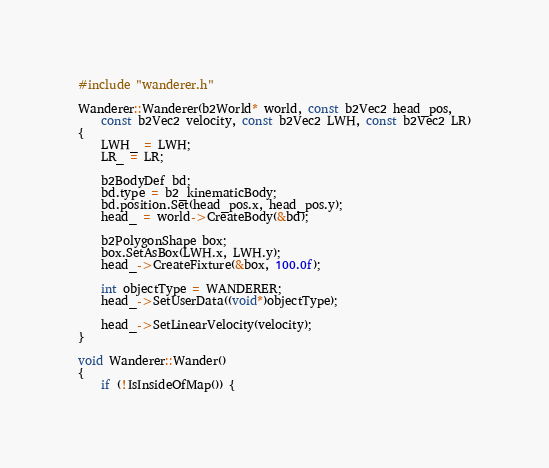Convert code to text. <code><loc_0><loc_0><loc_500><loc_500><_C++_>#include "wanderer.h"

Wanderer::Wanderer(b2World* world, const b2Vec2 head_pos,
    const b2Vec2 velocity, const b2Vec2 LWH, const b2Vec2 LR)
{
    LWH_ = LWH;
    LR_ = LR;

    b2BodyDef bd;
    bd.type = b2_kinematicBody;
    bd.position.Set(head_pos.x, head_pos.y);
    head_ = world->CreateBody(&bd);

    b2PolygonShape box;
    box.SetAsBox(LWH.x, LWH.y);
    head_->CreateFixture(&box, 100.0f);

    int objectType = WANDERER;
    head_->SetUserData((void*)objectType);

    head_->SetLinearVelocity(velocity);
}

void Wanderer::Wander()
{
    if (!IsInsideOfMap()) {</code> 